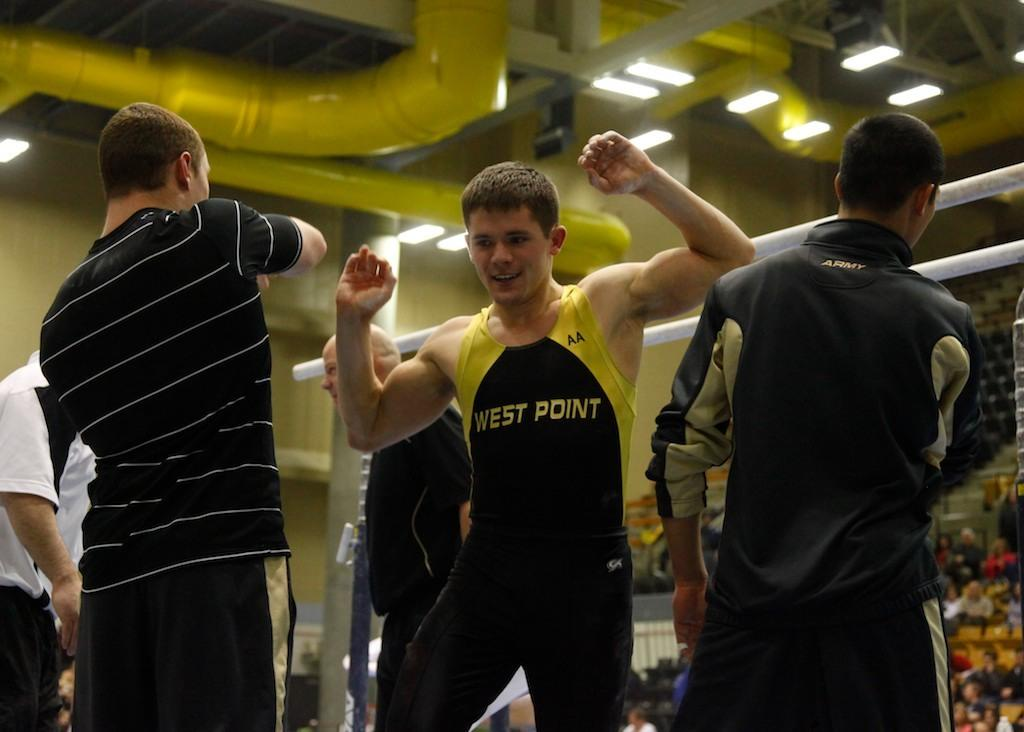Provide a one-sentence caption for the provided image. Men working out and exercising, while one man is wearing a west point workout shirt. 